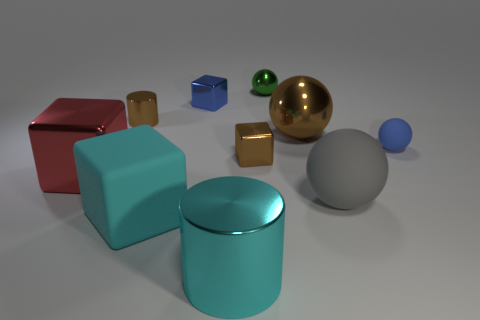Subtract 1 balls. How many balls are left? 3 Subtract all green balls. How many balls are left? 3 Subtract all small blue shiny cubes. How many cubes are left? 3 Subtract all yellow cubes. Subtract all brown cylinders. How many cubes are left? 4 Subtract all cubes. How many objects are left? 6 Add 1 large blocks. How many large blocks are left? 3 Add 6 small cyan shiny blocks. How many small cyan shiny blocks exist? 6 Subtract 0 yellow cylinders. How many objects are left? 10 Subtract all small red balls. Subtract all metal things. How many objects are left? 3 